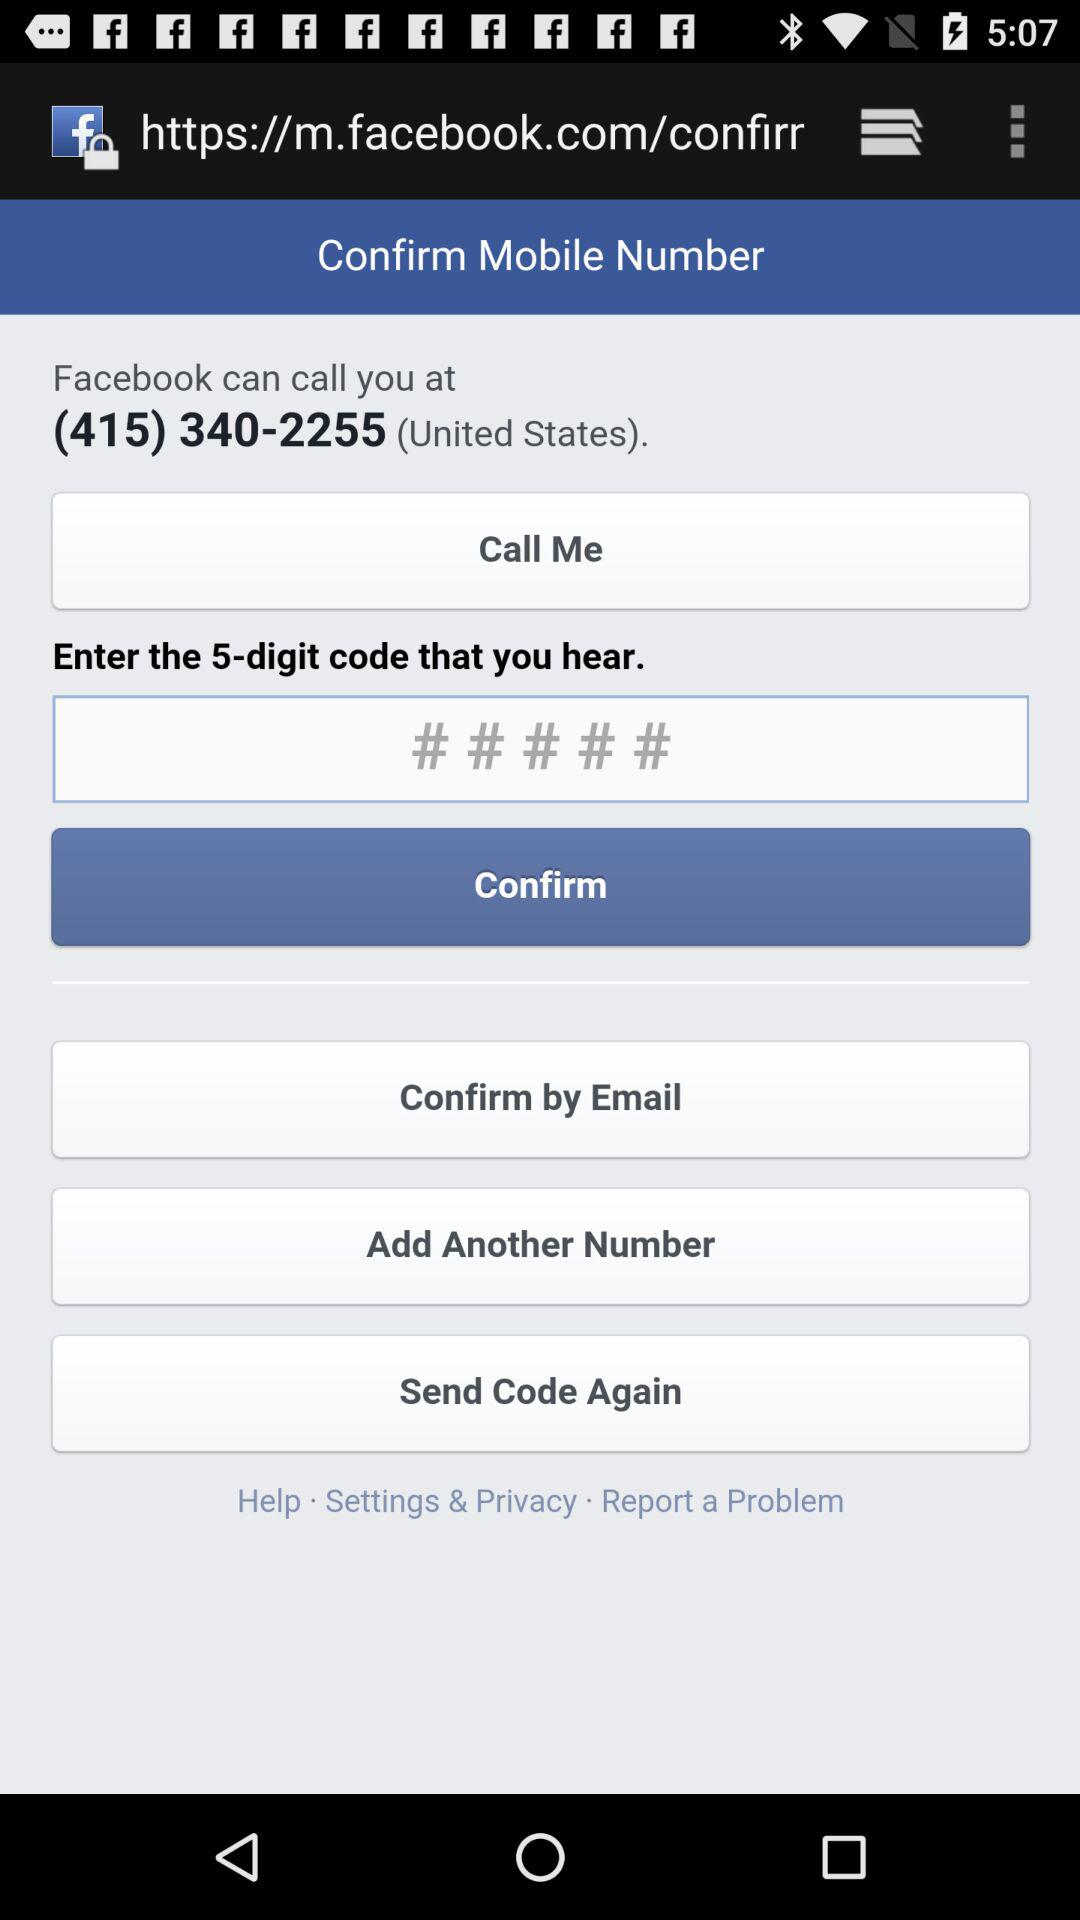How many different ways can I confirm my mobile number?
Answer the question using a single word or phrase. 3 